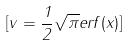Convert formula to latex. <formula><loc_0><loc_0><loc_500><loc_500>[ v = \frac { 1 } { 2 } \sqrt { \pi } e r f ( x ) ]</formula> 